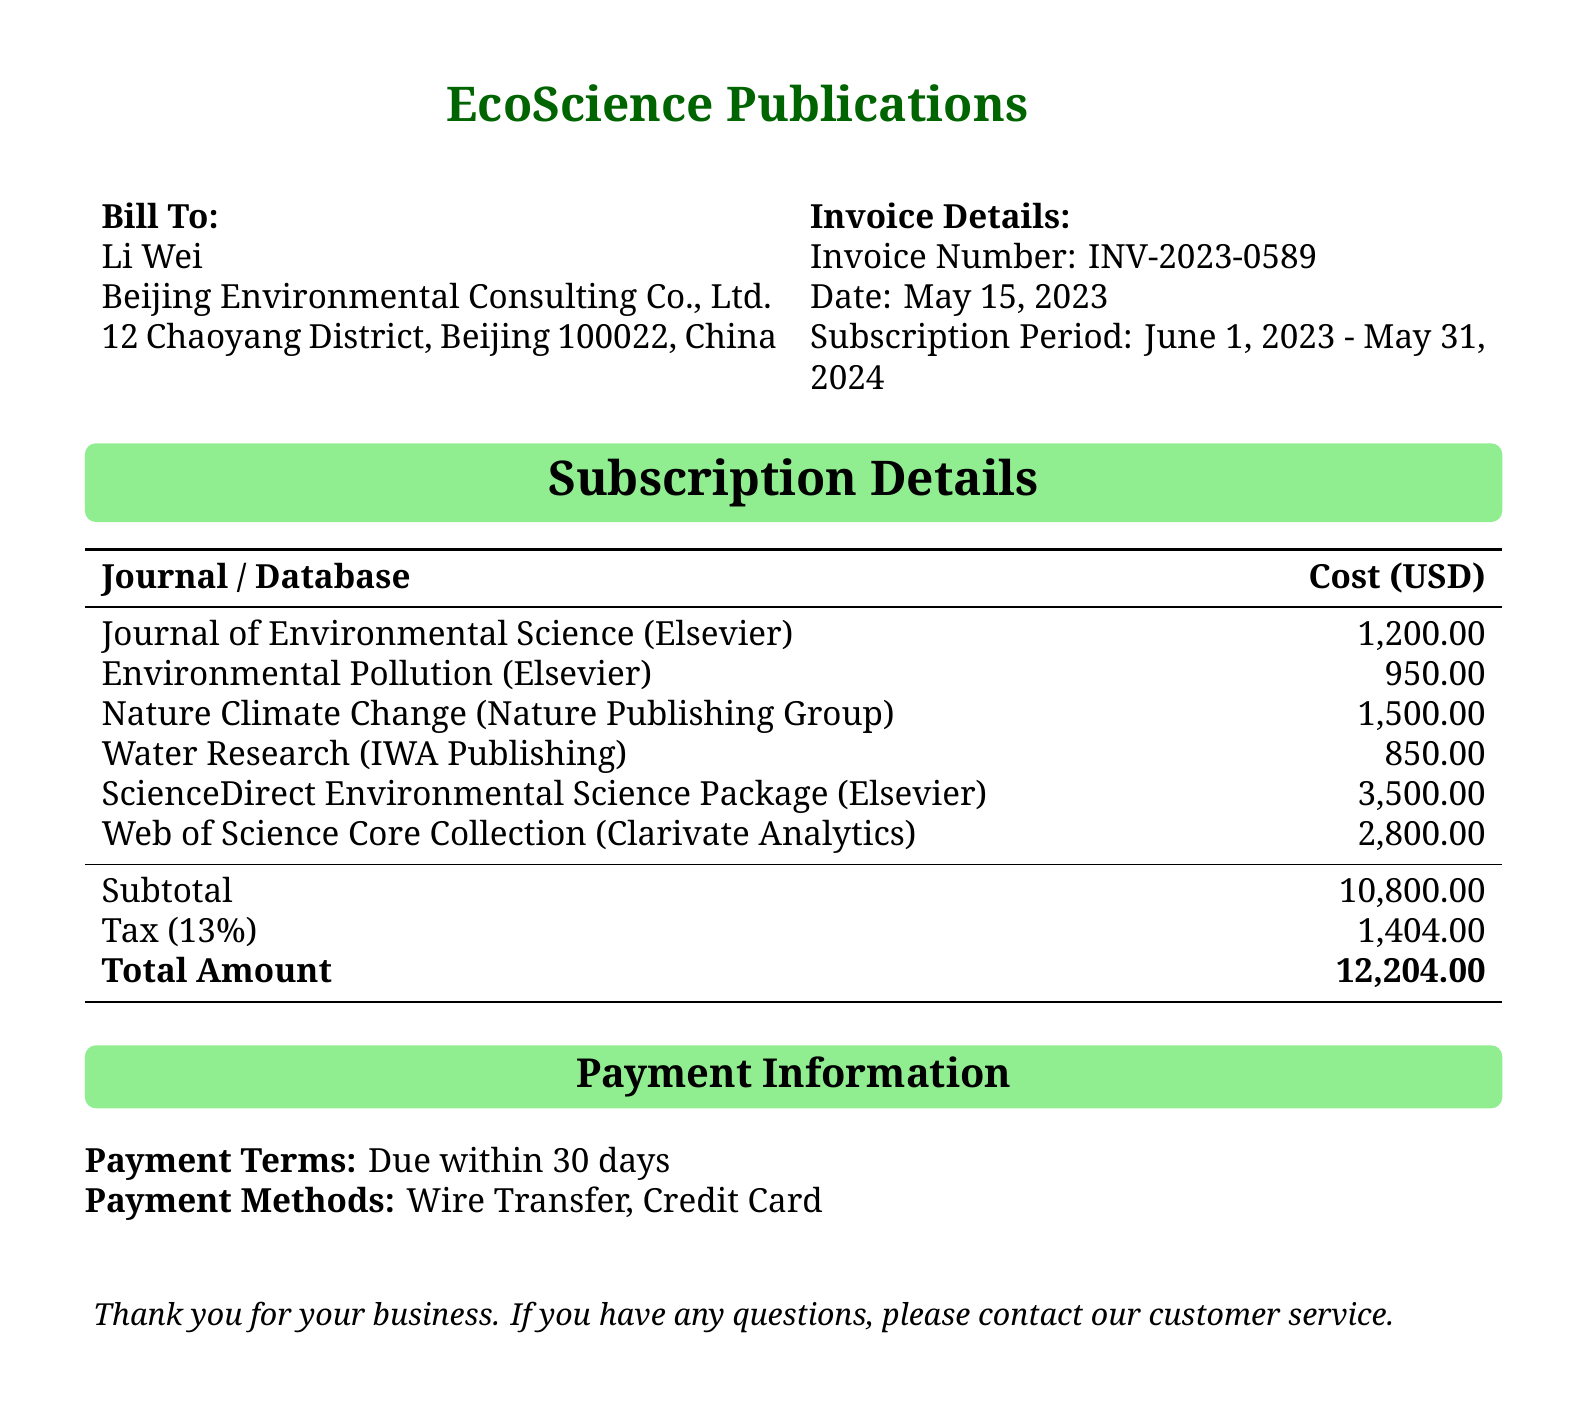What is the invoice number? The invoice number is a unique identifier for this billing statement, found in the document.
Answer: INV-2023-0589 What is the subscription period? The subscription period defines the time frame for which the subscriptions are valid, as stated in the document.
Answer: June 1, 2023 - May 31, 2024 Who is the billed entity? The document provides the name of the entity receiving the invoice, which is typically the customer.
Answer: Li Wei What is the total amount due? The total amount is the final sum that needs to be paid after tax and all subscriptions are included in the document.
Answer: 12,204.00 How much does the Journal of Environmental Science cost? The cost for each journal is detailed in the subscription details, specifically for the Journal of Environmental Science.
Answer: 1,200.00 What is the tax percentage applied? The tax percentage is calculated on the subtotal and is also listed within the billing details of the document.
Answer: 13% What is the payment term? The payment term specifies when the payment is due according to the document.
Answer: Due within 30 days Which company publishes the Nature Climate Change journal? The document names the publisher for each journal; this question asks for the publisher of a specific journal.
Answer: Nature Publishing Group How many individual subscriptions are listed? The number of subscriptions is determined by counting each entry in the subscription details section of the document.
Answer: 6 